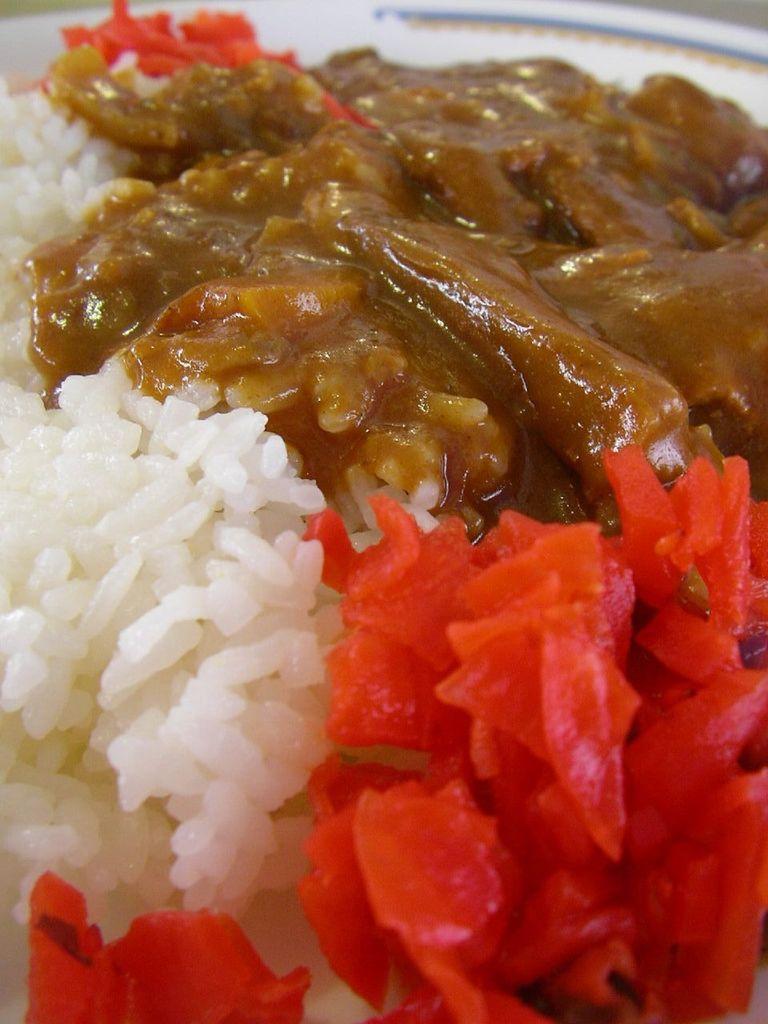Please provide a concise description of this image. In this picture I can see the food item in the plate. 